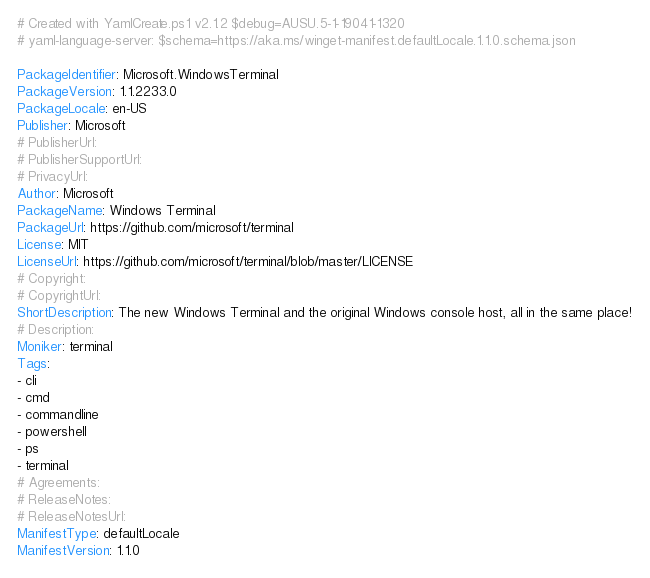<code> <loc_0><loc_0><loc_500><loc_500><_YAML_># Created with YamlCreate.ps1 v2.1.2 $debug=AUSU.5-1-19041-1320
# yaml-language-server: $schema=https://aka.ms/winget-manifest.defaultLocale.1.1.0.schema.json

PackageIdentifier: Microsoft.WindowsTerminal
PackageVersion: 1.1.2233.0
PackageLocale: en-US
Publisher: Microsoft
# PublisherUrl: 
# PublisherSupportUrl: 
# PrivacyUrl: 
Author: Microsoft
PackageName: Windows Terminal
PackageUrl: https://github.com/microsoft/terminal
License: MIT
LicenseUrl: https://github.com/microsoft/terminal/blob/master/LICENSE
# Copyright: 
# CopyrightUrl: 
ShortDescription: The new Windows Terminal and the original Windows console host, all in the same place!
# Description: 
Moniker: terminal
Tags:
- cli
- cmd
- commandline
- powershell
- ps
- terminal
# Agreements: 
# ReleaseNotes: 
# ReleaseNotesUrl: 
ManifestType: defaultLocale
ManifestVersion: 1.1.0
</code> 